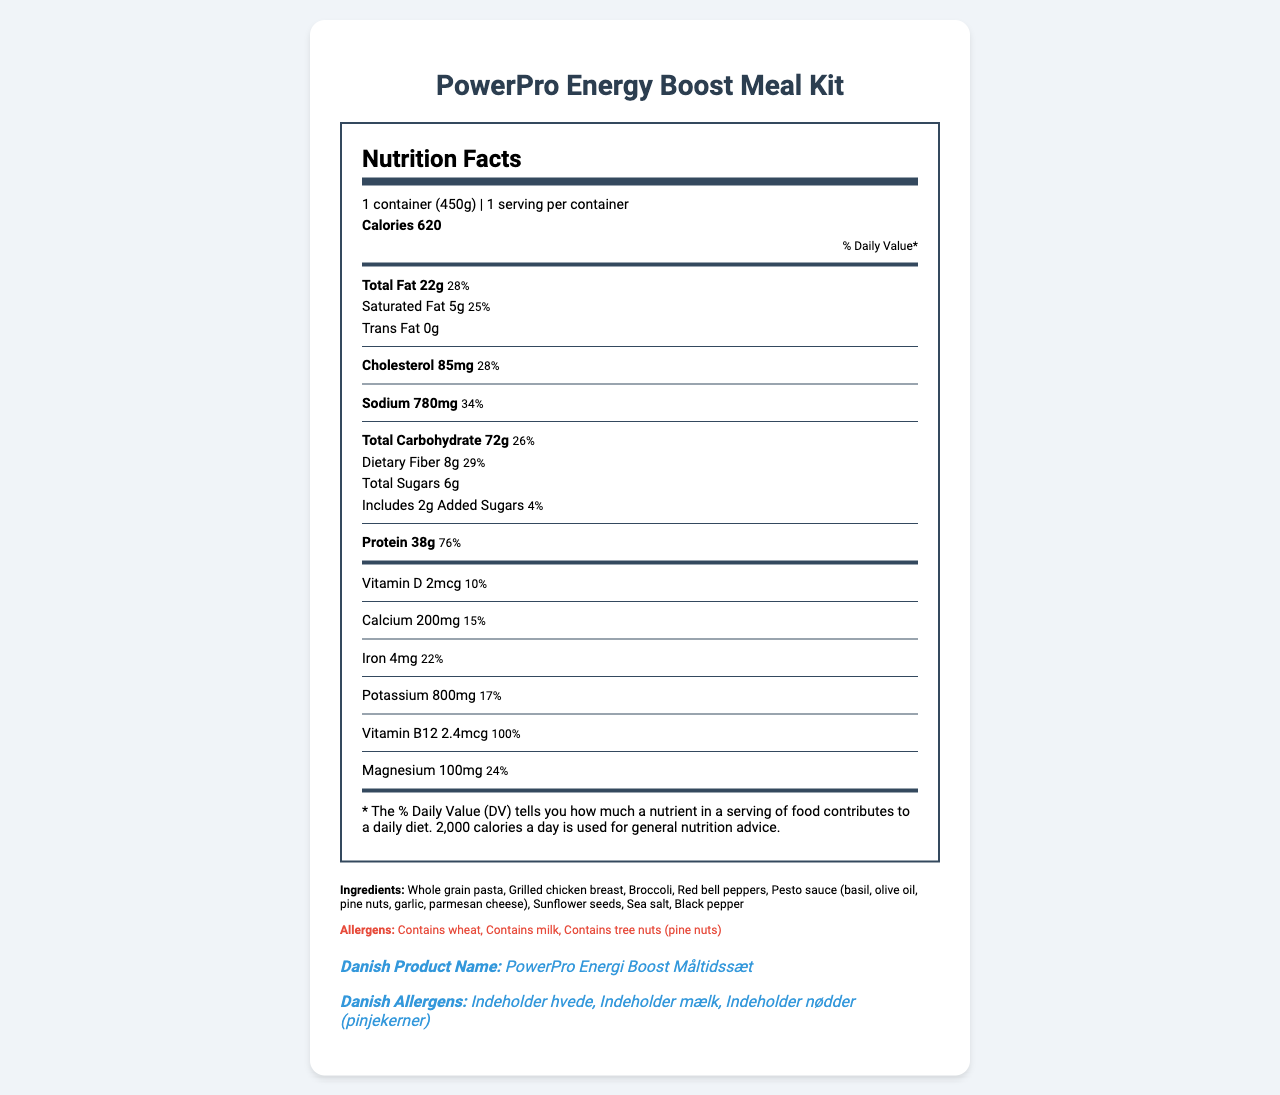what is the serving size? The serving size is clearly stated as "1 container (450g)" at the top of the Nutrition Facts section.
Answer: 1 container (450g) what is the total carbohydrate content per serving? The total carbohydrate content per serving is listed as 72g.
Answer: 72g how much protein does a single serving contain? The document specifies that a single serving contains 38g of protein.
Answer: 38g what percentage of the daily value for protein does one serving provide? According to the document, one serving provides 76% of the daily value for protein.
Answer: 76% which allergens are present in this meal kit? The allergens listed include wheat, milk, and tree nuts (pine nuts).
Answer: Wheat, milk, tree nuts (pine nuts) what is the amount of sodium in one serving? The sodium content in one serving is listed as 780mg.
Answer: 780mg how many grams of saturated fat are in one serving? One serving contains 5g of saturated fat.
Answer: 5g how much vitamin D is in one serving? The document lists the vitamin D content as 2 mcg per serving.
Answer: 2 mcg what is the daily value percentage for dietary fiber? The daily value percentage for dietary fiber is listed as 29%.
Answer: 29% what is the daily value percentage of calcium per serving? A. 10% B. 22% C. 15% D. 34% The document states that the daily value percentage of calcium per serving is 15%.
Answer: C. 15% what is the daily value percentage of vitamin B12 per serving? A. 30% B. 100% C. 75% D. 50% The daily value percentage for vitamin B12 per serving is listed as 100%.
Answer: B. 100% does this meal kit contain trans fat? The document indicates that the trans fat content is 0g, meaning it does not contain trans fat.
Answer: No do the heating instructions mention removing the lid before microwaving? The heating instructions specifically state to remove the lid before microwaving.
Answer: Yes describe the main idea of the document The document is a comprehensive overview of the nutritional content and usage instructions for the meal kit, highlighting its benefits for its target audience.
Answer: The document provides detailed nutritional information about the PowerPro Energy Boost Meal Kit, including its serving size, calorie content, macronutrients, vitamins, minerals, ingredients, allergens, storage, and heating instructions. The meal kit is designed for busy professionals in the energy sector and offers high protein and other nutritional benefits for sustained energy and cognitive function. how much vitamin C is in one serving? The document does not provide information about the vitamin C content in one serving.
Answer: Cannot be determined 